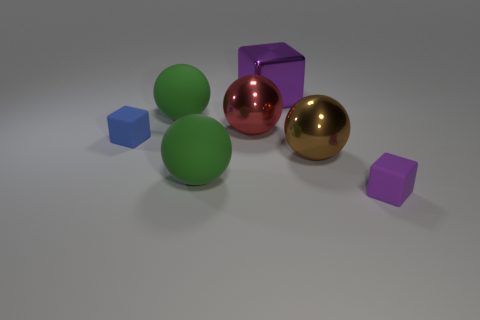Are any cyan spheres visible?
Give a very brief answer. No. There is a large red metallic sphere; are there any big purple metallic things in front of it?
Provide a succinct answer. No. There is a tiny purple thing that is the same shape as the large purple metal object; what is it made of?
Keep it short and to the point. Rubber. What number of other things are the same shape as the purple matte object?
Offer a very short reply. 2. How many big green rubber balls are to the left of the purple metal thing behind the small object to the right of the big purple thing?
Provide a succinct answer. 2. How many other things have the same shape as the brown thing?
Give a very brief answer. 3. There is a small block on the right side of the red object; does it have the same color as the large cube?
Ensure brevity in your answer.  Yes. There is a large purple metal thing to the left of the purple object in front of the purple cube left of the large brown thing; what shape is it?
Offer a terse response. Cube. Do the red thing and the purple thing that is to the right of the metal block have the same size?
Offer a terse response. No. Are there any rubber objects of the same size as the purple matte cube?
Offer a terse response. Yes. 